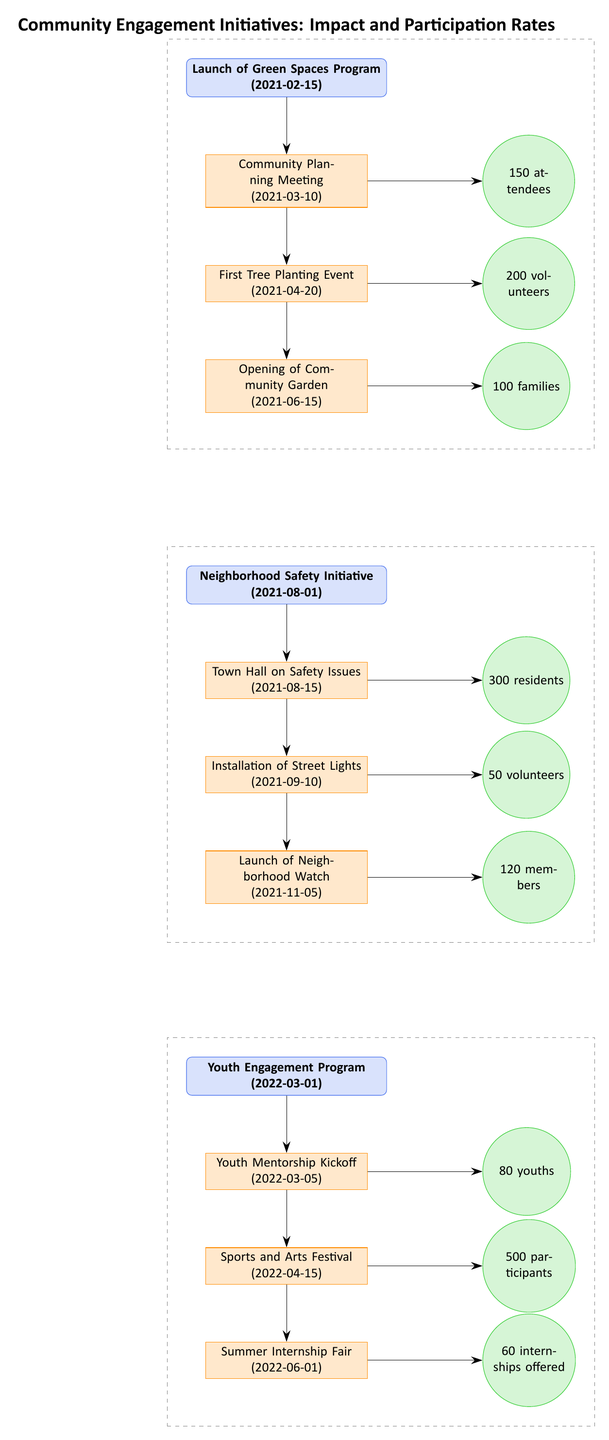What is the launch date of the Green Spaces Program? The Green Spaces Program is represented at the top of the diagram, and its launch date is indicated in parentheses right next to it as 2021-02-15.
Answer: 2021-02-15 How many attendees were there at the Community Planning Meeting? The Community Planning Meeting is linked to the Green Spaces Program, and the turnout is depicted to the right of the milestone, stating "150 attendees."
Answer: 150 attendees What is the milestone associated with the Neighborhood Safety Initiative that had the highest turnout? The milestones under the Neighborhood Safety Initiative indicate three events, and the Town Hall on Safety Issues, linked to 300 residents, is the highest turnout compared to the others.
Answer: Town Hall on Safety Issues How many volunteers participated in the First Tree Planting Event? The First Tree Planting Event is positioned below the Community Planning Meeting, with the turnout figure provided right next to it, stating "200 volunteers."
Answer: 200 volunteers What milestone followed the Opening of the Community Garden? In the flow of events under the Green Spaces Program, the milestone immediately after the Opening of the Community Garden is the Neighborhood Safety Initiative. This is determined by reading the sequence from top to bottom.
Answer: Neighborhood Safety Initiative What is the total turnout for the Youth Engagement Program milestones? The Youth Engagement Program has three milestones with respective turnouts of 80 youths, 500 participants, and 60 internships. Adding these together gives a total turnout of 640.
Answer: 640 Which initiative had the most recent launch date? The last initiative listed in the diagram is the Youth Engagement Program, launched on 2022-03-01, making it the most recent one.
Answer: Youth Engagement Program How many residents attended the Town Hall on Safety Issues? The Town Hall on Safety Issues is indicated under the Neighborhood Safety Initiative with a turnout number of "300 residents" noted next to it in the diagram.
Answer: 300 residents What was the first community involvement event for the Green Spaces Program? The first event associated with the Green Spaces Program, as shown in the diagram under its initial milestone, is the Community Planning Meeting, occurring on 2021-03-10.
Answer: Community Planning Meeting 